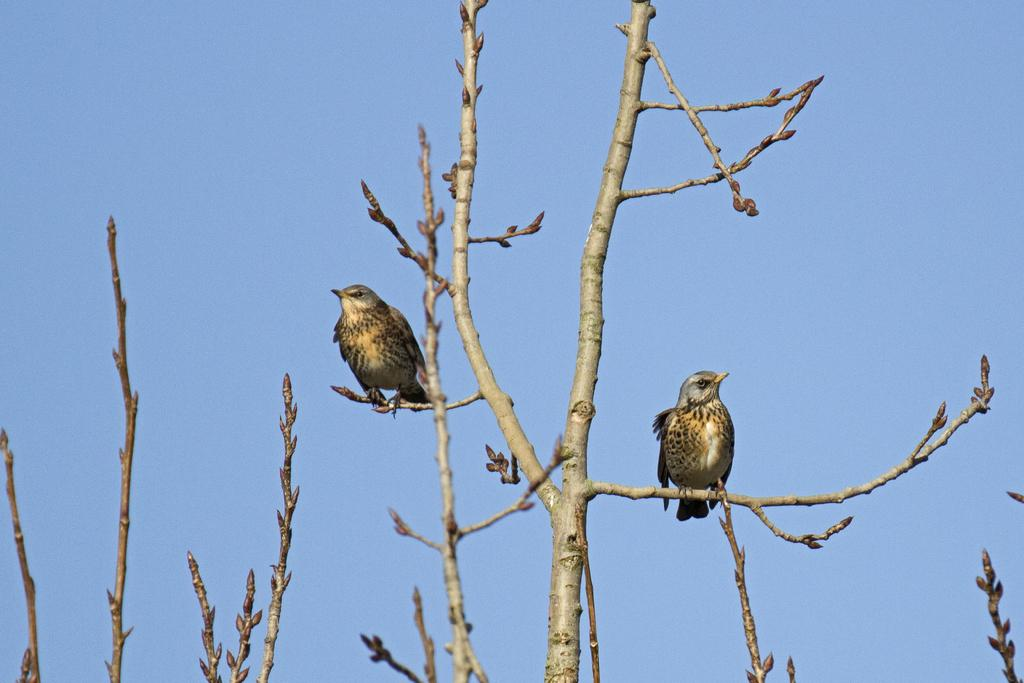What type of vegetation can be seen in the image? There are trees in the image. Are there any animals visible in the image? Yes, birds are present on the branches of the trees. What can be seen in the background of the image? The sky is visible in the background of the image. What type of car can be seen parked under the trees in the image? There is no car present in the image; it only features trees and birds. How does the root of the tree affect the stomach of the bird in the image? There is no mention of a bird's stomach or a tree's root in the image, so this question cannot be answered. 